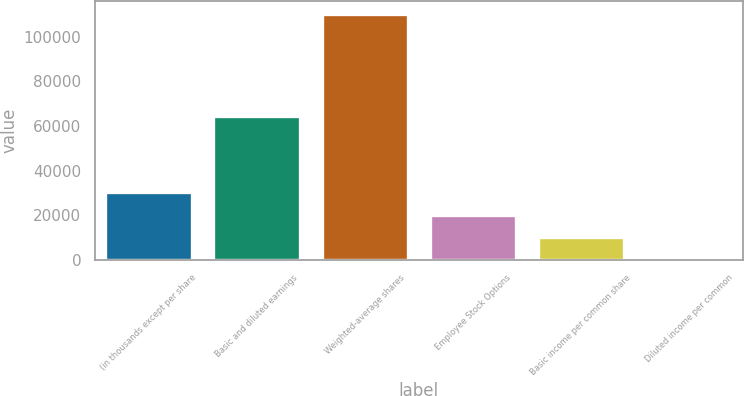Convert chart. <chart><loc_0><loc_0><loc_500><loc_500><bar_chart><fcel>(in thousands except per share<fcel>Basic and diluted earnings<fcel>Weighted-average shares<fcel>Employee Stock Options<fcel>Basic income per common share<fcel>Diluted income per common<nl><fcel>30423.2<fcel>64731<fcel>110440<fcel>20282.3<fcel>10141.5<fcel>0.64<nl></chart> 